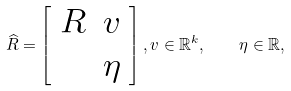<formula> <loc_0><loc_0><loc_500><loc_500>\widehat { R } = \left [ \begin{array} { c c } R & v \\ & \eta \end{array} \right ] , v \in \mathbb { R } ^ { k } , \quad \eta \in \mathbb { R } ,</formula> 